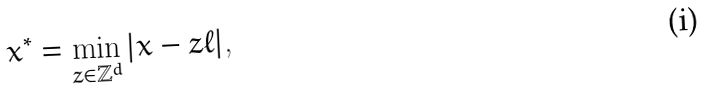Convert formula to latex. <formula><loc_0><loc_0><loc_500><loc_500>x ^ { * } = \min _ { z \in \mathbb { Z } ^ { d } } | x - z \ell | ,</formula> 